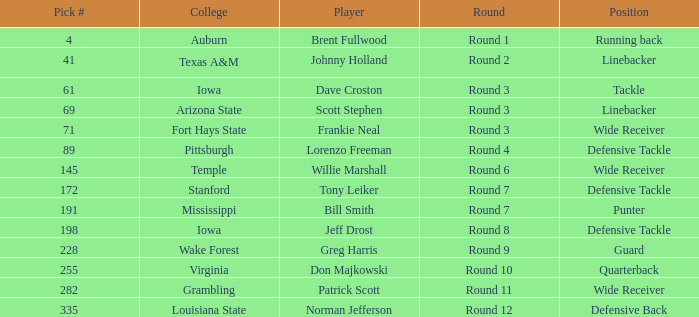What was the pick# for Lorenzo Freeman as defensive tackle? 89.0. 